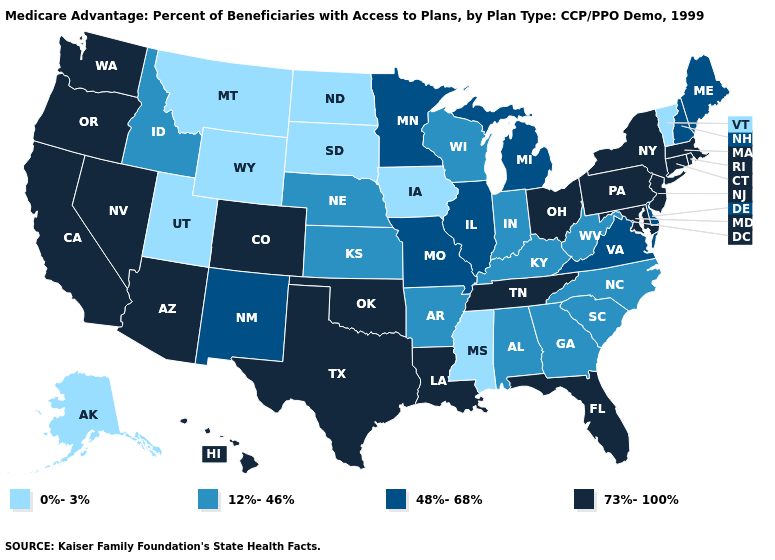What is the value of Georgia?
Short answer required. 12%-46%. Does Montana have the highest value in the West?
Short answer required. No. Name the states that have a value in the range 73%-100%?
Answer briefly. Arizona, California, Colorado, Connecticut, Florida, Hawaii, Louisiana, Massachusetts, Maryland, New Jersey, Nevada, New York, Ohio, Oklahoma, Oregon, Pennsylvania, Rhode Island, Tennessee, Texas, Washington. How many symbols are there in the legend?
Short answer required. 4. Name the states that have a value in the range 48%-68%?
Quick response, please. Delaware, Illinois, Maine, Michigan, Minnesota, Missouri, New Hampshire, New Mexico, Virginia. What is the value of Oklahoma?
Concise answer only. 73%-100%. What is the highest value in the USA?
Write a very short answer. 73%-100%. What is the highest value in the USA?
Give a very brief answer. 73%-100%. Name the states that have a value in the range 12%-46%?
Keep it brief. Alabama, Arkansas, Georgia, Idaho, Indiana, Kansas, Kentucky, North Carolina, Nebraska, South Carolina, Wisconsin, West Virginia. What is the lowest value in the South?
Be succinct. 0%-3%. Among the states that border Arkansas , which have the lowest value?
Write a very short answer. Mississippi. Which states have the lowest value in the Northeast?
Keep it brief. Vermont. Which states hav the highest value in the Northeast?
Concise answer only. Connecticut, Massachusetts, New Jersey, New York, Pennsylvania, Rhode Island. Name the states that have a value in the range 73%-100%?
Answer briefly. Arizona, California, Colorado, Connecticut, Florida, Hawaii, Louisiana, Massachusetts, Maryland, New Jersey, Nevada, New York, Ohio, Oklahoma, Oregon, Pennsylvania, Rhode Island, Tennessee, Texas, Washington. Among the states that border Oregon , does Washington have the highest value?
Short answer required. Yes. 